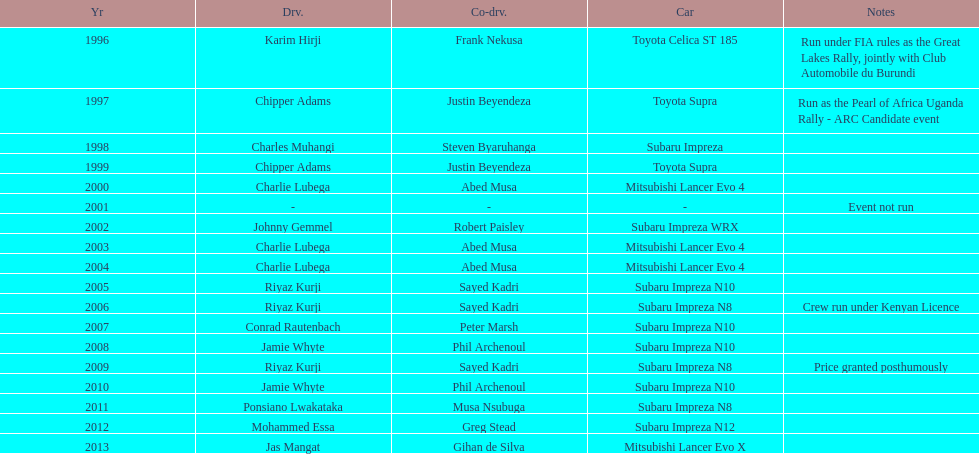Who was the only driver to win in a car other than a subaru impreza after the year 2005? Jas Mangat. 